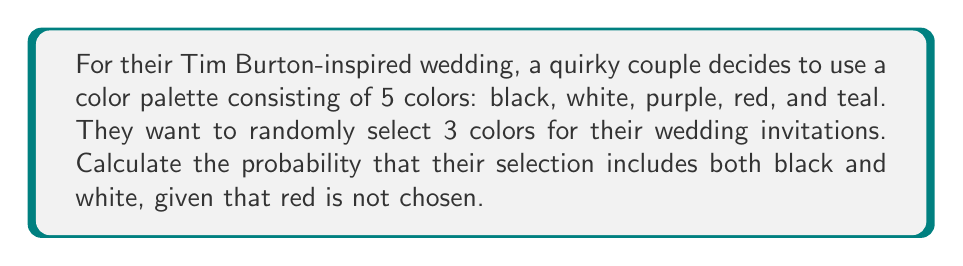Could you help me with this problem? Let's approach this step-by-step:

1) First, we need to calculate the total number of ways to choose 3 colors from 5 colors:
   $$\binom{5}{3} = \frac{5!}{3!(5-3)!} = \frac{5 \cdot 4 \cdot 3}{3 \cdot 2 \cdot 1} = 10$$

2) Now, we're given that red is not chosen. This leaves us with 4 colors to choose from: black, white, purple, and teal.

3) We want both black and white to be included. So we need to choose these two colors and then select 1 more color from the remaining 2 (purple and teal).

4) The number of ways to choose 1 color from 2 colors is:
   $$\binom{2}{1} = 2$$

5) Therefore, there is only 1 way to choose both black and white, and 2 ways to choose the third color.

6) The probability is thus:
   $$P(\text{black and white | red not chosen}) = \frac{\text{favorable outcomes}}{\text{total outcomes}} = \frac{1 \cdot 2}{\binom{4}{3}}$$

7) We need to calculate $\binom{4}{3}$:
   $$\binom{4}{3} = \frac{4!}{3!(4-3)!} = \frac{4 \cdot 3 \cdot 2}{3 \cdot 2 \cdot 1} = 4$$

8) Therefore, the final probability is:
   $$P(\text{black and white | red not chosen}) = \frac{2}{4} = \frac{1}{2} = 0.5$$
Answer: $\frac{1}{2}$ or $0.5$ or $50\%$ 